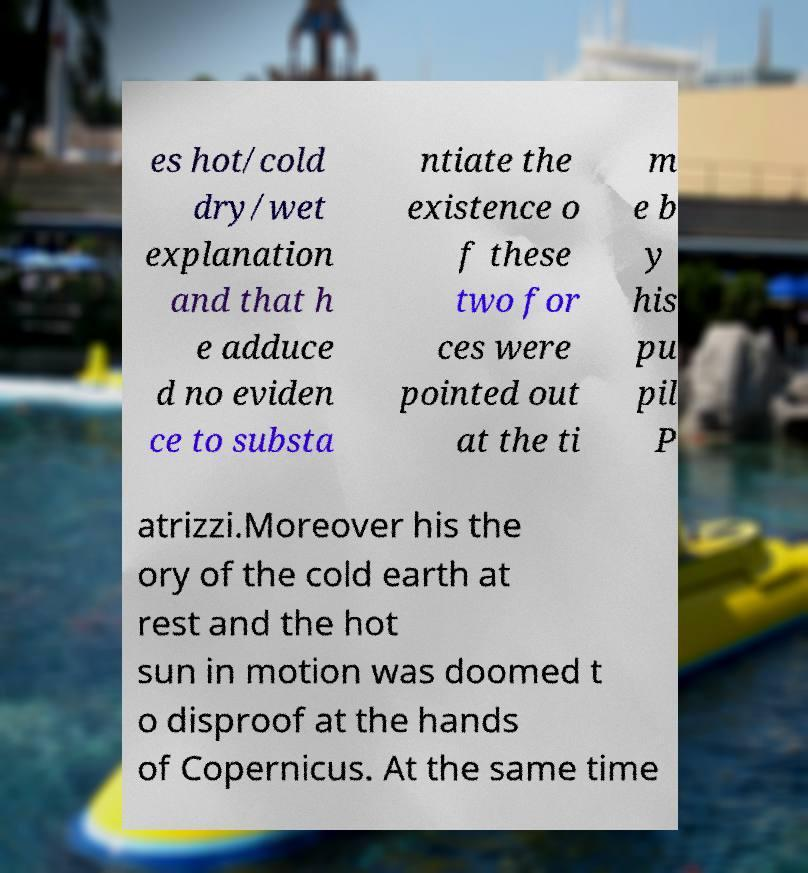Please identify and transcribe the text found in this image. es hot/cold dry/wet explanation and that h e adduce d no eviden ce to substa ntiate the existence o f these two for ces were pointed out at the ti m e b y his pu pil P atrizzi.Moreover his the ory of the cold earth at rest and the hot sun in motion was doomed t o disproof at the hands of Copernicus. At the same time 